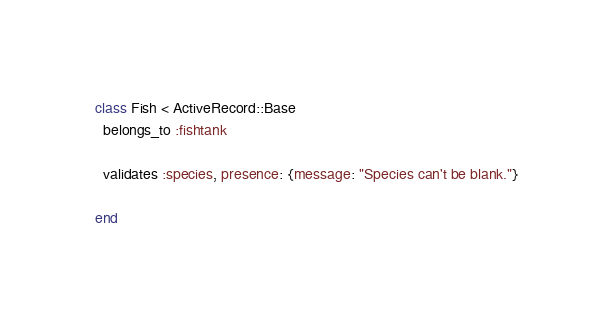Convert code to text. <code><loc_0><loc_0><loc_500><loc_500><_Ruby_>class Fish < ActiveRecord::Base 
  belongs_to :fishtank
  
  validates :species, presence: {message: "Species can't be blank."}
  
end </code> 